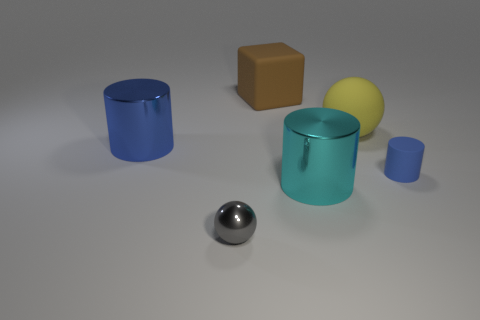The other large object that is the same shape as the cyan object is what color?
Ensure brevity in your answer.  Blue. Does the gray ball have the same material as the tiny cylinder?
Offer a very short reply. No. Does the blue cylinder in front of the large blue shiny cylinder have the same size as the shiny thing to the right of the metallic sphere?
Your answer should be compact. No. Are there fewer rubber objects than large yellow shiny things?
Offer a terse response. No. How many metal objects are either big brown cubes or red things?
Offer a terse response. 0. Are there any yellow rubber balls in front of the blue cylinder left of the tiny sphere?
Give a very brief answer. No. Do the tiny object that is in front of the small rubber cylinder and the large block have the same material?
Make the answer very short. No. How many other objects are the same color as the metal ball?
Give a very brief answer. 0. Is the matte cylinder the same color as the block?
Offer a terse response. No. There is a blue cylinder that is on the right side of the thing that is left of the gray shiny ball; what is its size?
Give a very brief answer. Small. 